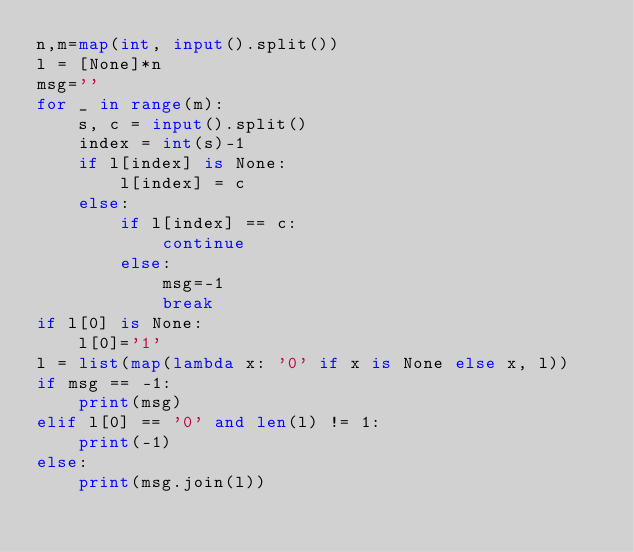Convert code to text. <code><loc_0><loc_0><loc_500><loc_500><_Python_>n,m=map(int, input().split())
l = [None]*n
msg=''
for _ in range(m):
    s, c = input().split()
    index = int(s)-1
    if l[index] is None:
        l[index] = c
    else:
        if l[index] == c:
            continue
        else:
            msg=-1
            break
if l[0] is None:
    l[0]='1'
l = list(map(lambda x: '0' if x is None else x, l))
if msg == -1:
    print(msg)
elif l[0] == '0' and len(l) != 1:
    print(-1)
else:
    print(msg.join(l))
</code> 